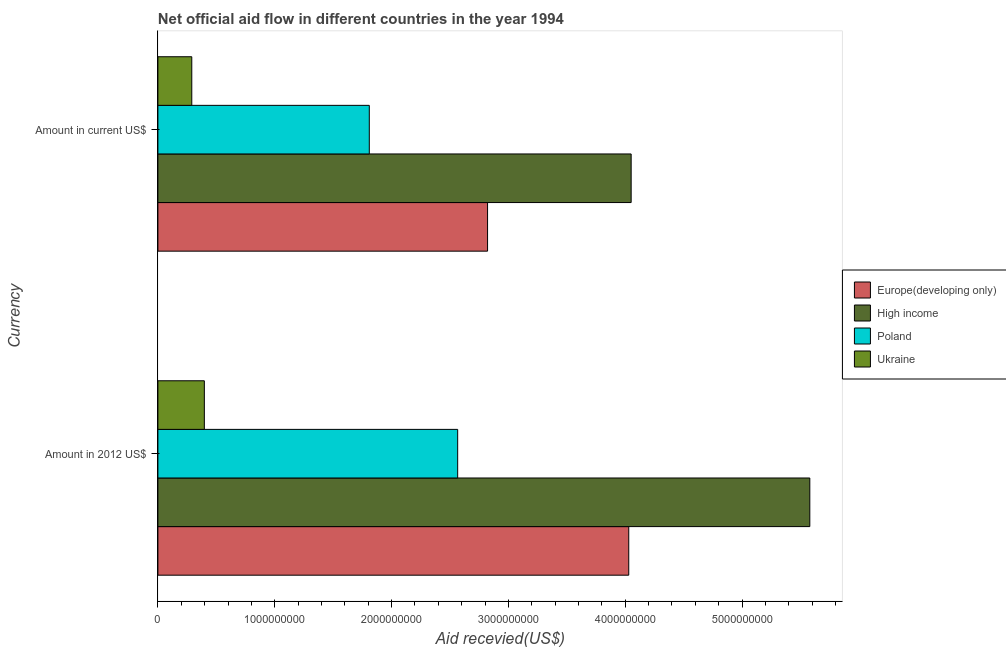Are the number of bars per tick equal to the number of legend labels?
Your response must be concise. Yes. How many bars are there on the 2nd tick from the bottom?
Make the answer very short. 4. What is the label of the 2nd group of bars from the top?
Give a very brief answer. Amount in 2012 US$. What is the amount of aid received(expressed in 2012 us$) in High income?
Your answer should be compact. 5.58e+09. Across all countries, what is the maximum amount of aid received(expressed in us$)?
Keep it short and to the point. 4.05e+09. Across all countries, what is the minimum amount of aid received(expressed in 2012 us$)?
Ensure brevity in your answer.  3.97e+08. In which country was the amount of aid received(expressed in 2012 us$) minimum?
Make the answer very short. Ukraine. What is the total amount of aid received(expressed in 2012 us$) in the graph?
Your response must be concise. 1.26e+1. What is the difference between the amount of aid received(expressed in 2012 us$) in Poland and that in High income?
Offer a terse response. -3.01e+09. What is the difference between the amount of aid received(expressed in 2012 us$) in High income and the amount of aid received(expressed in us$) in Europe(developing only)?
Keep it short and to the point. 2.76e+09. What is the average amount of aid received(expressed in us$) per country?
Make the answer very short. 2.24e+09. What is the difference between the amount of aid received(expressed in us$) and amount of aid received(expressed in 2012 us$) in Ukraine?
Your answer should be very brief. -1.08e+08. In how many countries, is the amount of aid received(expressed in us$) greater than 200000000 US$?
Your response must be concise. 4. What is the ratio of the amount of aid received(expressed in us$) in Ukraine to that in Europe(developing only)?
Offer a very short reply. 0.1. In how many countries, is the amount of aid received(expressed in 2012 us$) greater than the average amount of aid received(expressed in 2012 us$) taken over all countries?
Offer a very short reply. 2. What does the 4th bar from the top in Amount in 2012 US$ represents?
Your response must be concise. Europe(developing only). What does the 1st bar from the bottom in Amount in current US$ represents?
Ensure brevity in your answer.  Europe(developing only). Are all the bars in the graph horizontal?
Provide a short and direct response. Yes. Are the values on the major ticks of X-axis written in scientific E-notation?
Give a very brief answer. No. Does the graph contain any zero values?
Offer a very short reply. No. How many legend labels are there?
Offer a terse response. 4. What is the title of the graph?
Ensure brevity in your answer.  Net official aid flow in different countries in the year 1994. Does "Iraq" appear as one of the legend labels in the graph?
Make the answer very short. No. What is the label or title of the X-axis?
Your response must be concise. Aid recevied(US$). What is the label or title of the Y-axis?
Your response must be concise. Currency. What is the Aid recevied(US$) of Europe(developing only) in Amount in 2012 US$?
Offer a very short reply. 4.03e+09. What is the Aid recevied(US$) in High income in Amount in 2012 US$?
Offer a terse response. 5.58e+09. What is the Aid recevied(US$) in Poland in Amount in 2012 US$?
Offer a terse response. 2.57e+09. What is the Aid recevied(US$) of Ukraine in Amount in 2012 US$?
Give a very brief answer. 3.97e+08. What is the Aid recevied(US$) in Europe(developing only) in Amount in current US$?
Make the answer very short. 2.82e+09. What is the Aid recevied(US$) in High income in Amount in current US$?
Give a very brief answer. 4.05e+09. What is the Aid recevied(US$) in Poland in Amount in current US$?
Offer a very short reply. 1.81e+09. What is the Aid recevied(US$) of Ukraine in Amount in current US$?
Your answer should be compact. 2.90e+08. Across all Currency, what is the maximum Aid recevied(US$) in Europe(developing only)?
Make the answer very short. 4.03e+09. Across all Currency, what is the maximum Aid recevied(US$) of High income?
Your response must be concise. 5.58e+09. Across all Currency, what is the maximum Aid recevied(US$) in Poland?
Your answer should be compact. 2.57e+09. Across all Currency, what is the maximum Aid recevied(US$) of Ukraine?
Give a very brief answer. 3.97e+08. Across all Currency, what is the minimum Aid recevied(US$) of Europe(developing only)?
Offer a terse response. 2.82e+09. Across all Currency, what is the minimum Aid recevied(US$) in High income?
Ensure brevity in your answer.  4.05e+09. Across all Currency, what is the minimum Aid recevied(US$) of Poland?
Offer a terse response. 1.81e+09. Across all Currency, what is the minimum Aid recevied(US$) in Ukraine?
Give a very brief answer. 2.90e+08. What is the total Aid recevied(US$) of Europe(developing only) in the graph?
Offer a very short reply. 6.85e+09. What is the total Aid recevied(US$) of High income in the graph?
Provide a short and direct response. 9.63e+09. What is the total Aid recevied(US$) in Poland in the graph?
Make the answer very short. 4.38e+09. What is the total Aid recevied(US$) in Ukraine in the graph?
Offer a terse response. 6.87e+08. What is the difference between the Aid recevied(US$) of Europe(developing only) in Amount in 2012 US$ and that in Amount in current US$?
Offer a terse response. 1.21e+09. What is the difference between the Aid recevied(US$) of High income in Amount in 2012 US$ and that in Amount in current US$?
Provide a succinct answer. 1.53e+09. What is the difference between the Aid recevied(US$) in Poland in Amount in 2012 US$ and that in Amount in current US$?
Your answer should be very brief. 7.57e+08. What is the difference between the Aid recevied(US$) of Ukraine in Amount in 2012 US$ and that in Amount in current US$?
Provide a short and direct response. 1.08e+08. What is the difference between the Aid recevied(US$) of Europe(developing only) in Amount in 2012 US$ and the Aid recevied(US$) of High income in Amount in current US$?
Offer a terse response. -2.06e+07. What is the difference between the Aid recevied(US$) in Europe(developing only) in Amount in 2012 US$ and the Aid recevied(US$) in Poland in Amount in current US$?
Offer a terse response. 2.22e+09. What is the difference between the Aid recevied(US$) of Europe(developing only) in Amount in 2012 US$ and the Aid recevied(US$) of Ukraine in Amount in current US$?
Offer a very short reply. 3.74e+09. What is the difference between the Aid recevied(US$) of High income in Amount in 2012 US$ and the Aid recevied(US$) of Poland in Amount in current US$?
Keep it short and to the point. 3.77e+09. What is the difference between the Aid recevied(US$) of High income in Amount in 2012 US$ and the Aid recevied(US$) of Ukraine in Amount in current US$?
Your response must be concise. 5.29e+09. What is the difference between the Aid recevied(US$) of Poland in Amount in 2012 US$ and the Aid recevied(US$) of Ukraine in Amount in current US$?
Give a very brief answer. 2.28e+09. What is the average Aid recevied(US$) in Europe(developing only) per Currency?
Your answer should be very brief. 3.43e+09. What is the average Aid recevied(US$) in High income per Currency?
Your answer should be compact. 4.82e+09. What is the average Aid recevied(US$) of Poland per Currency?
Ensure brevity in your answer.  2.19e+09. What is the average Aid recevied(US$) of Ukraine per Currency?
Your answer should be very brief. 3.44e+08. What is the difference between the Aid recevied(US$) of Europe(developing only) and Aid recevied(US$) of High income in Amount in 2012 US$?
Your response must be concise. -1.55e+09. What is the difference between the Aid recevied(US$) of Europe(developing only) and Aid recevied(US$) of Poland in Amount in 2012 US$?
Your answer should be very brief. 1.46e+09. What is the difference between the Aid recevied(US$) in Europe(developing only) and Aid recevied(US$) in Ukraine in Amount in 2012 US$?
Offer a very short reply. 3.63e+09. What is the difference between the Aid recevied(US$) of High income and Aid recevied(US$) of Poland in Amount in 2012 US$?
Provide a succinct answer. 3.01e+09. What is the difference between the Aid recevied(US$) of High income and Aid recevied(US$) of Ukraine in Amount in 2012 US$?
Make the answer very short. 5.18e+09. What is the difference between the Aid recevied(US$) in Poland and Aid recevied(US$) in Ukraine in Amount in 2012 US$?
Offer a terse response. 2.17e+09. What is the difference between the Aid recevied(US$) in Europe(developing only) and Aid recevied(US$) in High income in Amount in current US$?
Make the answer very short. -1.23e+09. What is the difference between the Aid recevied(US$) in Europe(developing only) and Aid recevied(US$) in Poland in Amount in current US$?
Keep it short and to the point. 1.01e+09. What is the difference between the Aid recevied(US$) in Europe(developing only) and Aid recevied(US$) in Ukraine in Amount in current US$?
Keep it short and to the point. 2.53e+09. What is the difference between the Aid recevied(US$) in High income and Aid recevied(US$) in Poland in Amount in current US$?
Provide a short and direct response. 2.24e+09. What is the difference between the Aid recevied(US$) in High income and Aid recevied(US$) in Ukraine in Amount in current US$?
Ensure brevity in your answer.  3.76e+09. What is the difference between the Aid recevied(US$) in Poland and Aid recevied(US$) in Ukraine in Amount in current US$?
Make the answer very short. 1.52e+09. What is the ratio of the Aid recevied(US$) of Europe(developing only) in Amount in 2012 US$ to that in Amount in current US$?
Your answer should be very brief. 1.43. What is the ratio of the Aid recevied(US$) in High income in Amount in 2012 US$ to that in Amount in current US$?
Provide a succinct answer. 1.38. What is the ratio of the Aid recevied(US$) of Poland in Amount in 2012 US$ to that in Amount in current US$?
Offer a very short reply. 1.42. What is the ratio of the Aid recevied(US$) in Ukraine in Amount in 2012 US$ to that in Amount in current US$?
Your answer should be compact. 1.37. What is the difference between the highest and the second highest Aid recevied(US$) in Europe(developing only)?
Provide a short and direct response. 1.21e+09. What is the difference between the highest and the second highest Aid recevied(US$) of High income?
Your answer should be very brief. 1.53e+09. What is the difference between the highest and the second highest Aid recevied(US$) in Poland?
Keep it short and to the point. 7.57e+08. What is the difference between the highest and the second highest Aid recevied(US$) of Ukraine?
Give a very brief answer. 1.08e+08. What is the difference between the highest and the lowest Aid recevied(US$) of Europe(developing only)?
Provide a succinct answer. 1.21e+09. What is the difference between the highest and the lowest Aid recevied(US$) in High income?
Provide a succinct answer. 1.53e+09. What is the difference between the highest and the lowest Aid recevied(US$) in Poland?
Offer a terse response. 7.57e+08. What is the difference between the highest and the lowest Aid recevied(US$) of Ukraine?
Offer a very short reply. 1.08e+08. 